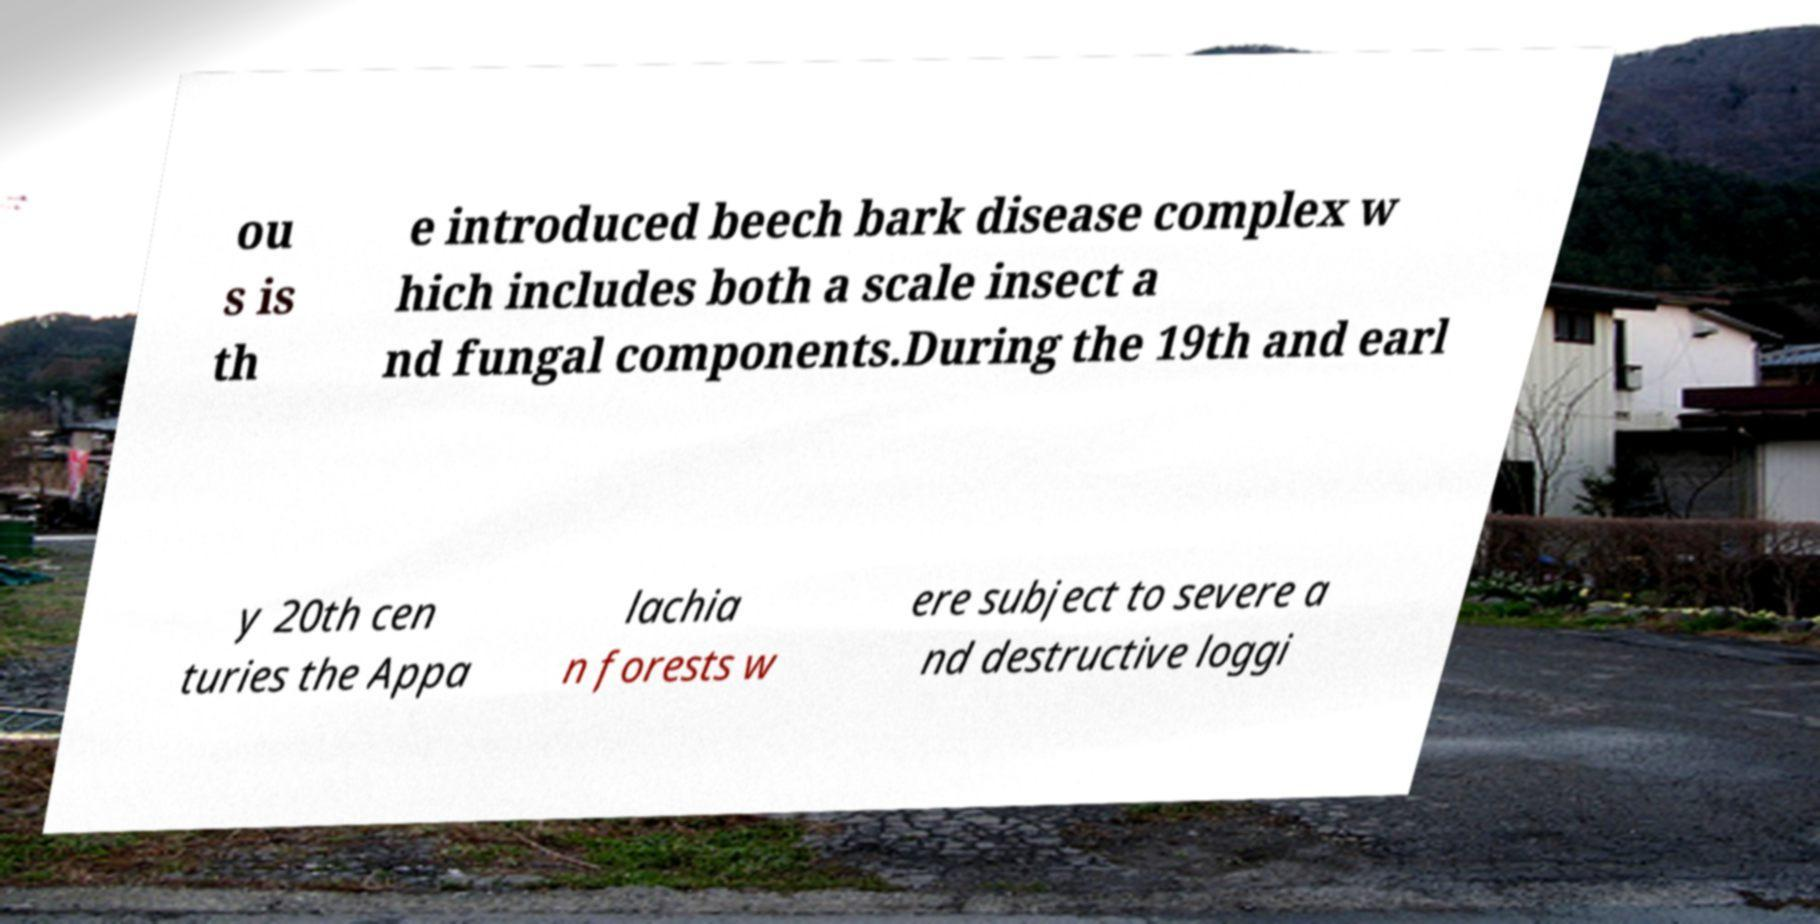Could you assist in decoding the text presented in this image and type it out clearly? ou s is th e introduced beech bark disease complex w hich includes both a scale insect a nd fungal components.During the 19th and earl y 20th cen turies the Appa lachia n forests w ere subject to severe a nd destructive loggi 